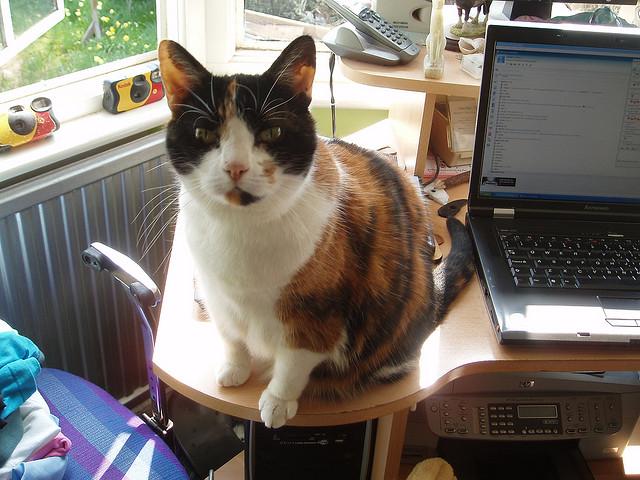Are there two cameras on the windowsill?
Quick response, please. Yes. What type of cat is this?
Keep it brief. Calico. Is the laptop on?
Keep it brief. Yes. 